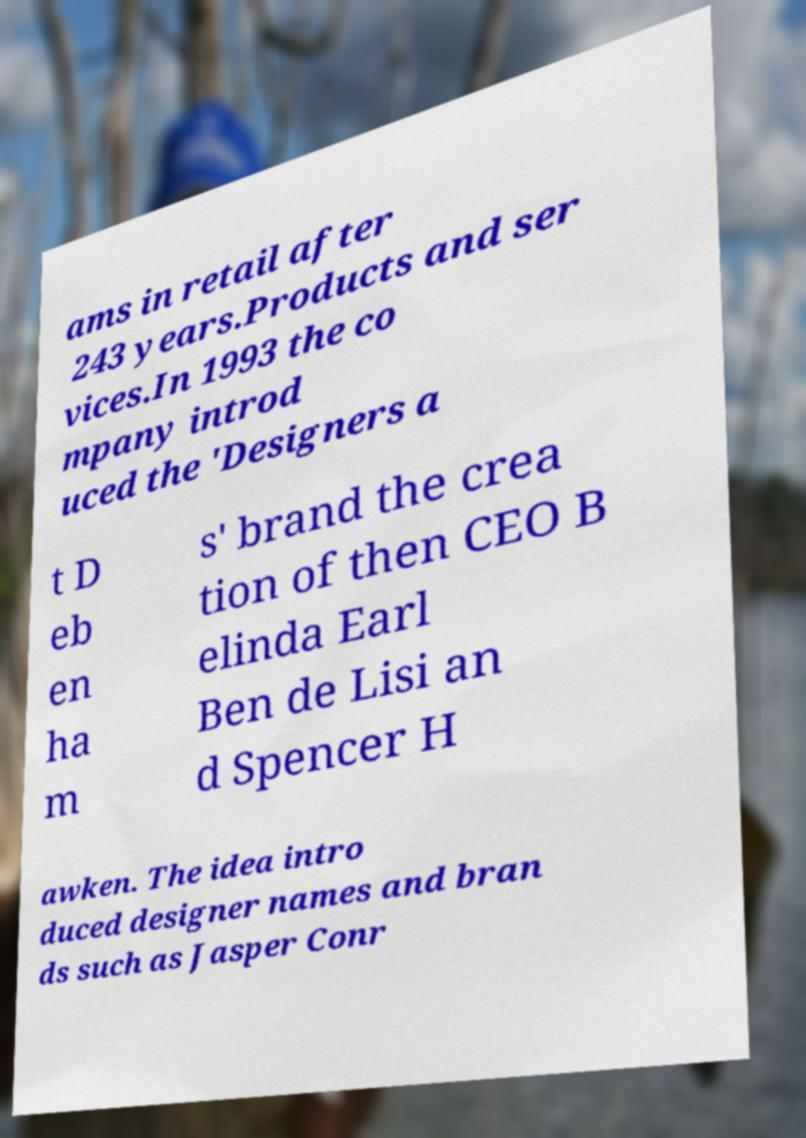Please read and relay the text visible in this image. What does it say? ams in retail after 243 years.Products and ser vices.In 1993 the co mpany introd uced the 'Designers a t D eb en ha m s' brand the crea tion of then CEO B elinda Earl Ben de Lisi an d Spencer H awken. The idea intro duced designer names and bran ds such as Jasper Conr 